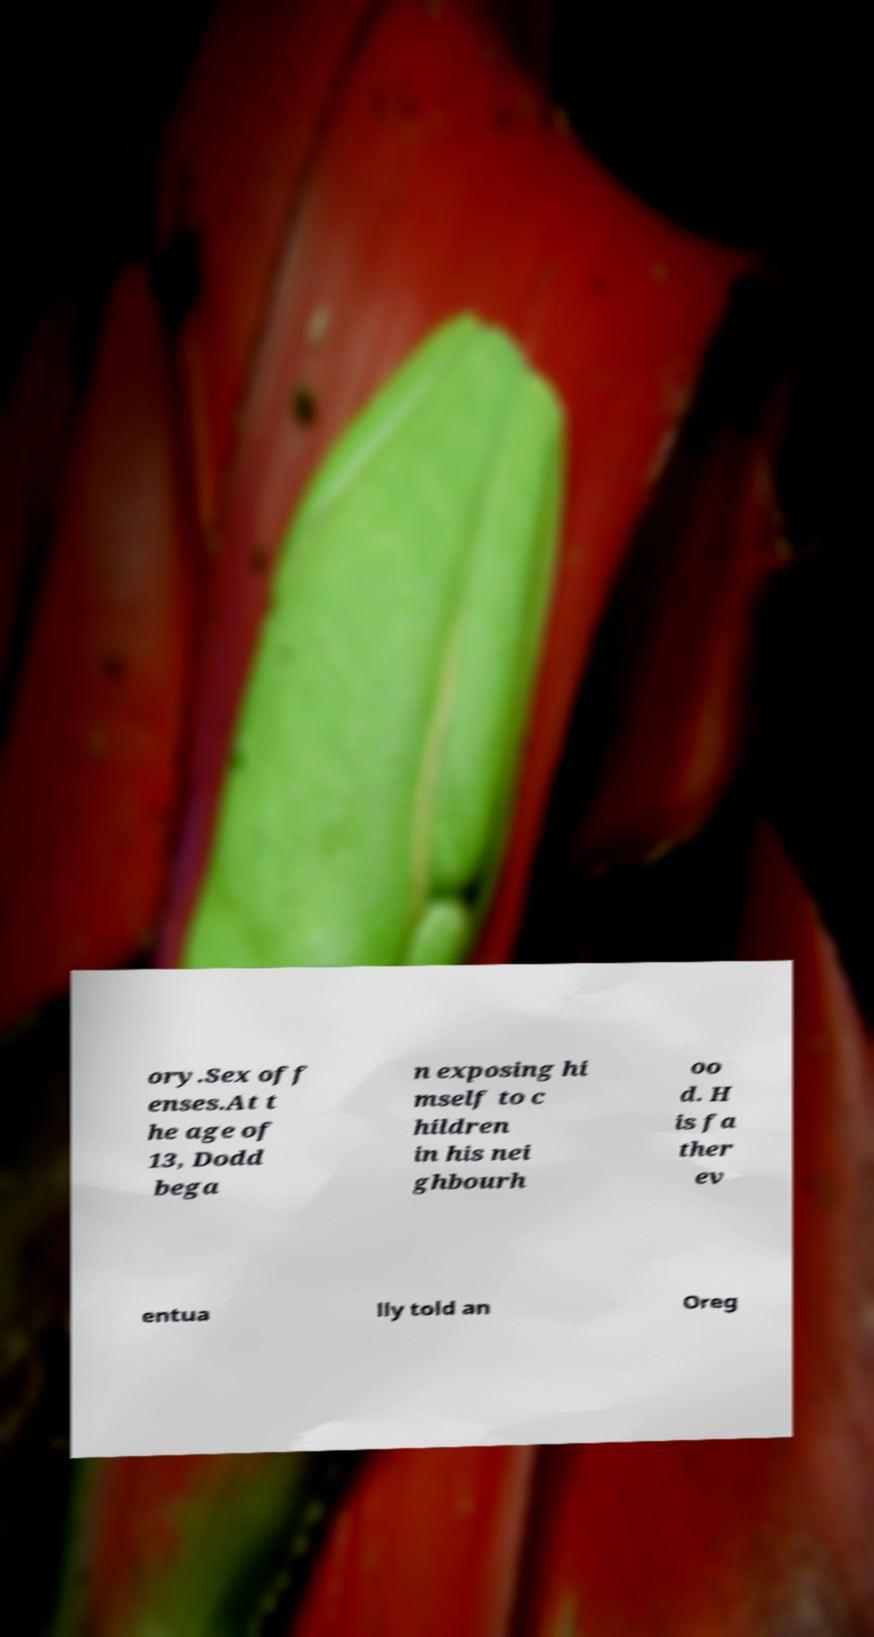There's text embedded in this image that I need extracted. Can you transcribe it verbatim? ory.Sex off enses.At t he age of 13, Dodd bega n exposing hi mself to c hildren in his nei ghbourh oo d. H is fa ther ev entua lly told an Oreg 